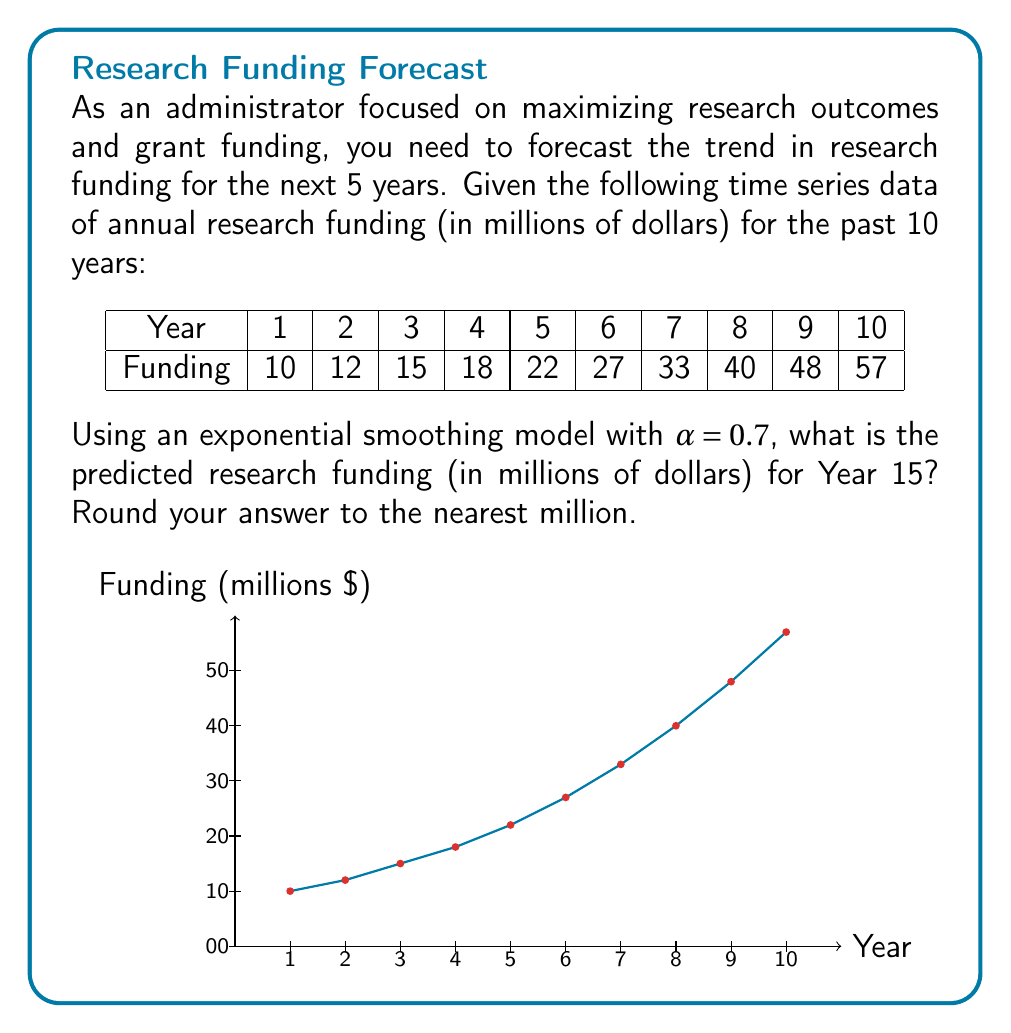Can you answer this question? To solve this problem, we'll use the exponential smoothing model to forecast the research funding for Year 15. The steps are as follows:

1) The exponential smoothing formula is:
   $$ F_{t+1} = \alpha Y_t + (1-\alpha)F_t $$
   where $F_{t+1}$ is the forecast for the next period, $Y_t$ is the actual value at time $t$, and $F_t$ is the forecast for the current period.

2) We start with the last known value ($57 million) as our initial forecast.

3) We then apply the formula iteratively for Years 11 to 15:

   Year 11: $F_{11} = 0.7(57) + 0.3(57) = 57$
   Year 12: $F_{12} = 0.7(57) + 0.3(57) = 57$
   Year 13: $F_{13} = 0.7(57) + 0.3(57) = 57$
   Year 14: $F_{14} = 0.7(57) + 0.3(57) = 57$
   Year 15: $F_{15} = 0.7(57) + 0.3(57) = 57$

4) The forecast remains constant at $57 million because we don't have actual values for Years 11-14, so the model keeps using the last known value.

5) Rounding to the nearest million, our final answer is $57 million.

Note: This simple exponential smoothing model assumes a constant level and doesn't account for the clear upward trend in the data. For more accurate forecasts, considering a trend-adjusted exponential smoothing or more advanced time series models would be advisable.
Answer: $57 million 